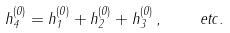<formula> <loc_0><loc_0><loc_500><loc_500>h ^ { ( 0 ) } _ { 4 } = h ^ { ( 0 ) } _ { 1 } + h ^ { ( 0 ) } _ { 2 } + h ^ { ( 0 ) } _ { 3 } \, , \quad e t c .</formula> 